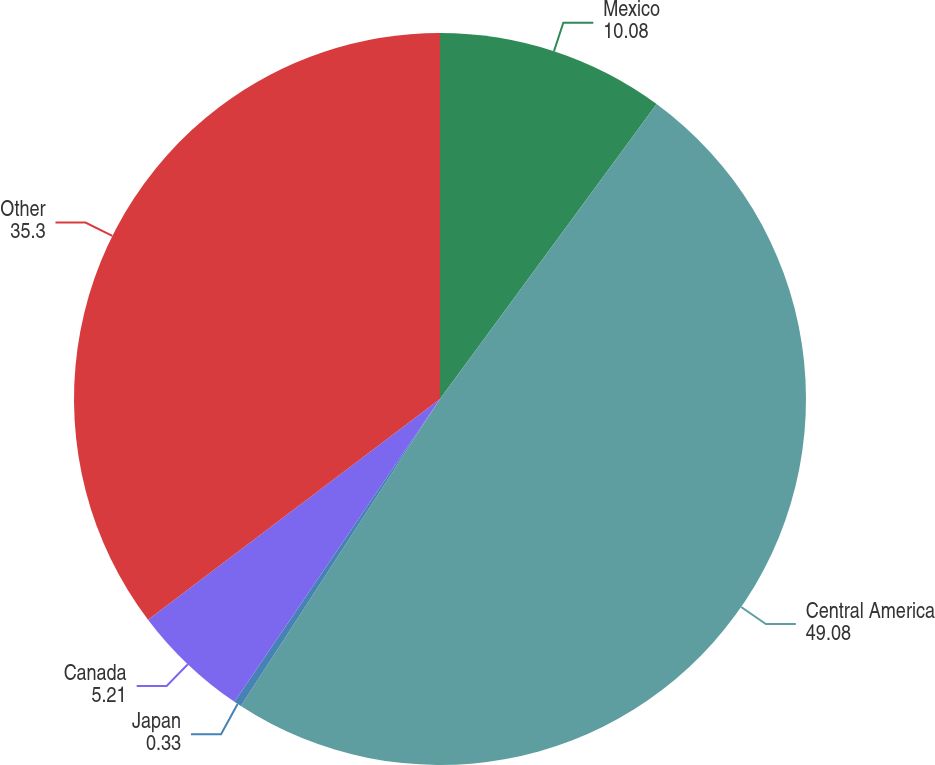Convert chart to OTSL. <chart><loc_0><loc_0><loc_500><loc_500><pie_chart><fcel>Mexico<fcel>Central America<fcel>Japan<fcel>Canada<fcel>Other<nl><fcel>10.08%<fcel>49.08%<fcel>0.33%<fcel>5.21%<fcel>35.3%<nl></chart> 